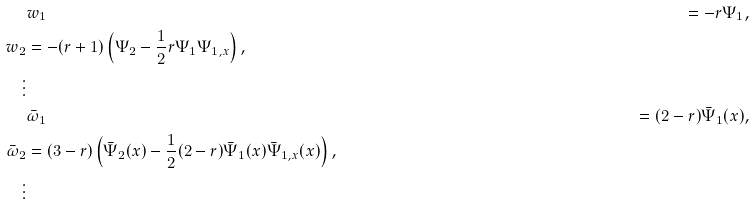<formula> <loc_0><loc_0><loc_500><loc_500>& w _ { 1 } & = - r \Psi _ { 1 } , \\ w _ { 2 } & = - ( r + 1 ) \left ( \Psi _ { 2 } - \frac { 1 } { 2 } r \Psi _ { 1 } \Psi _ { 1 , x } \right ) , \\ \vdots & \\ & \bar { \omega } _ { 1 } & = ( 2 - r ) \bar { \Psi } _ { 1 } ( x ) , \\ \bar { \omega } _ { 2 } & = ( 3 - r ) \left ( \bar { \Psi } _ { 2 } ( x ) - \frac { 1 } { 2 } ( 2 - r ) \bar { \Psi } _ { 1 } ( x ) \bar { \Psi } _ { 1 , x } ( x ) \right ) , \\ \vdots &</formula> 